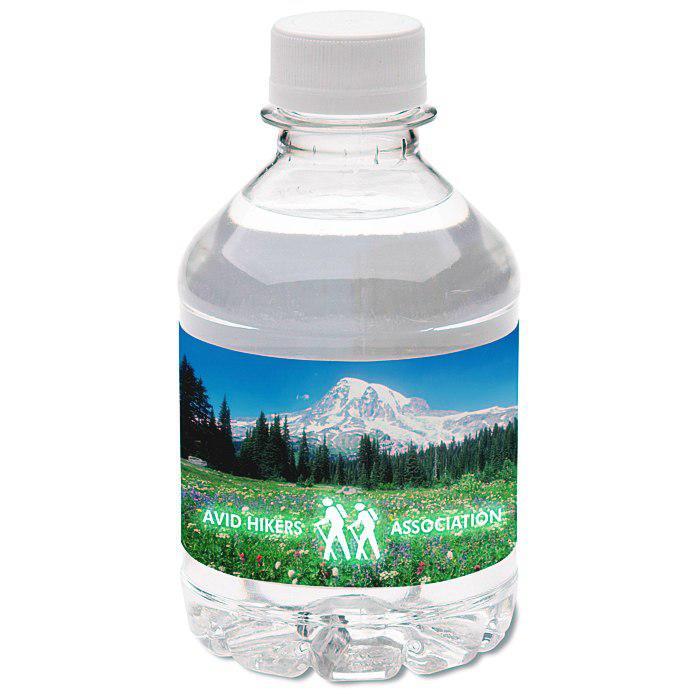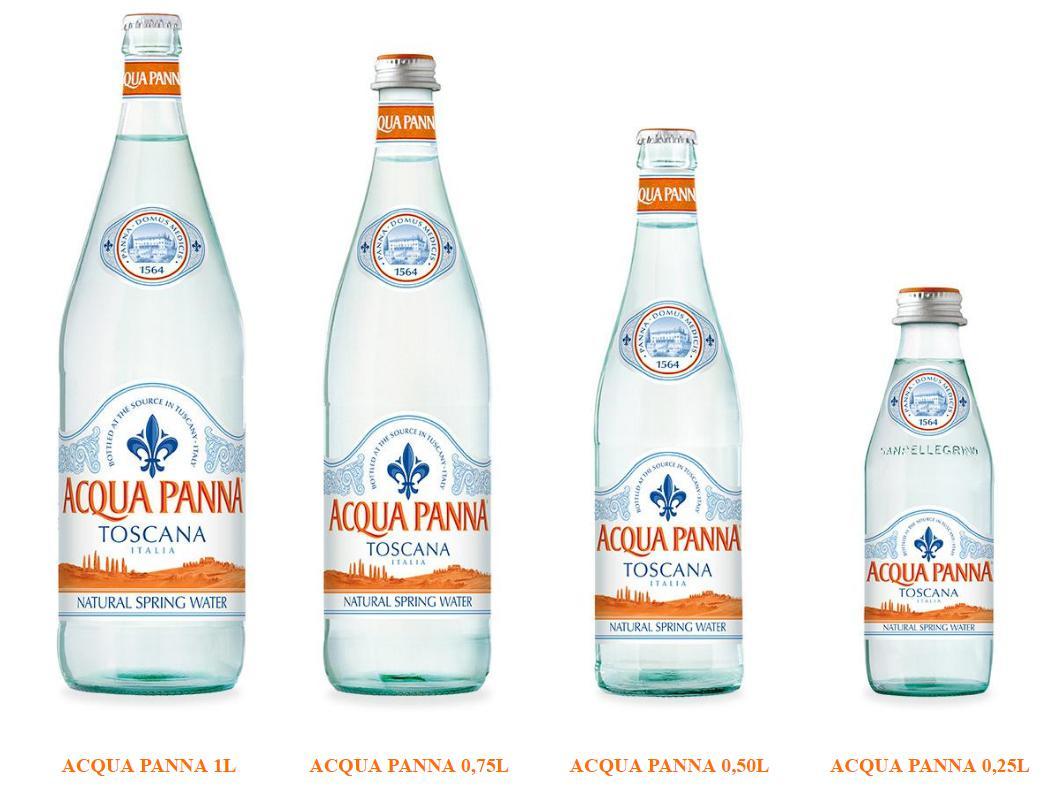The first image is the image on the left, the second image is the image on the right. Analyze the images presented: Is the assertion "The bottle on the right has a blue label." valid? Answer yes or no. No. The first image is the image on the left, the second image is the image on the right. Evaluate the accuracy of this statement regarding the images: "One of the bottles has a Kirkland label.". Is it true? Answer yes or no. No. 